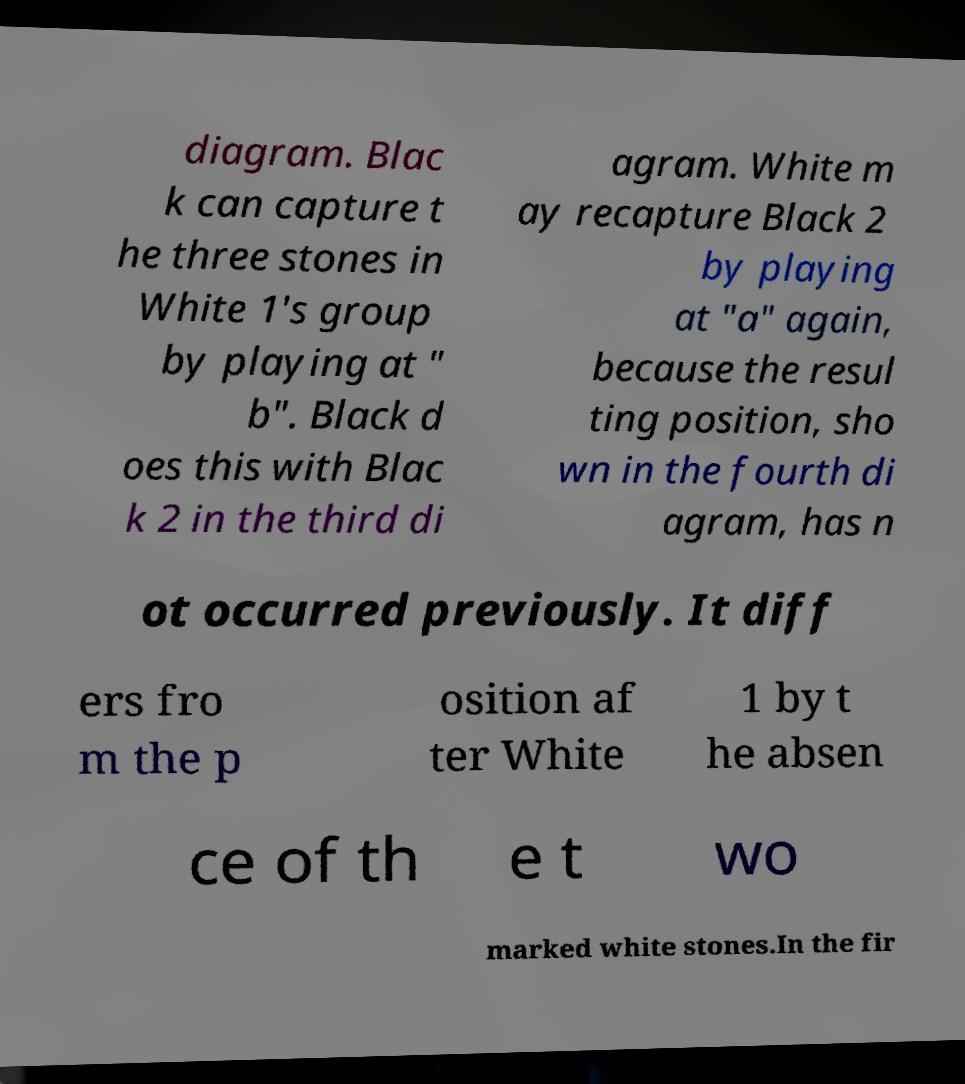Could you extract and type out the text from this image? diagram. Blac k can capture t he three stones in White 1's group by playing at " b". Black d oes this with Blac k 2 in the third di agram. White m ay recapture Black 2 by playing at "a" again, because the resul ting position, sho wn in the fourth di agram, has n ot occurred previously. It diff ers fro m the p osition af ter White 1 by t he absen ce of th e t wo marked white stones.In the fir 